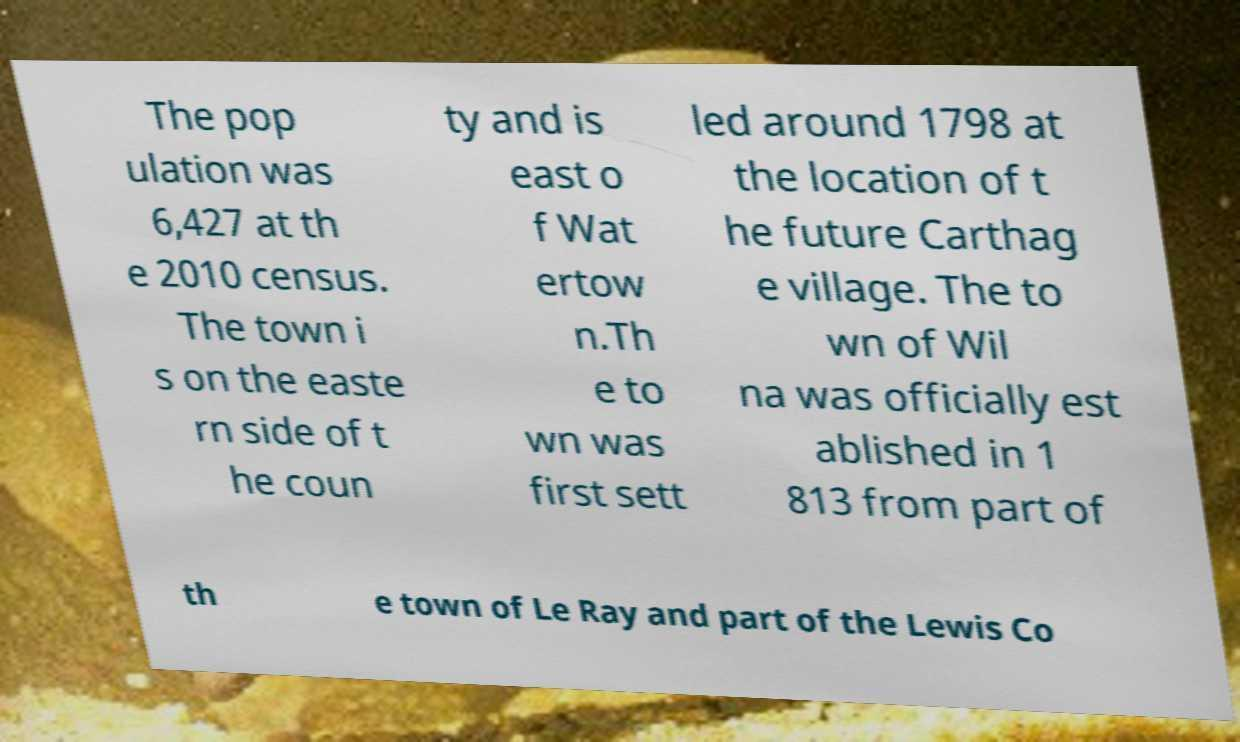Please identify and transcribe the text found in this image. The pop ulation was 6,427 at th e 2010 census. The town i s on the easte rn side of t he coun ty and is east o f Wat ertow n.Th e to wn was first sett led around 1798 at the location of t he future Carthag e village. The to wn of Wil na was officially est ablished in 1 813 from part of th e town of Le Ray and part of the Lewis Co 